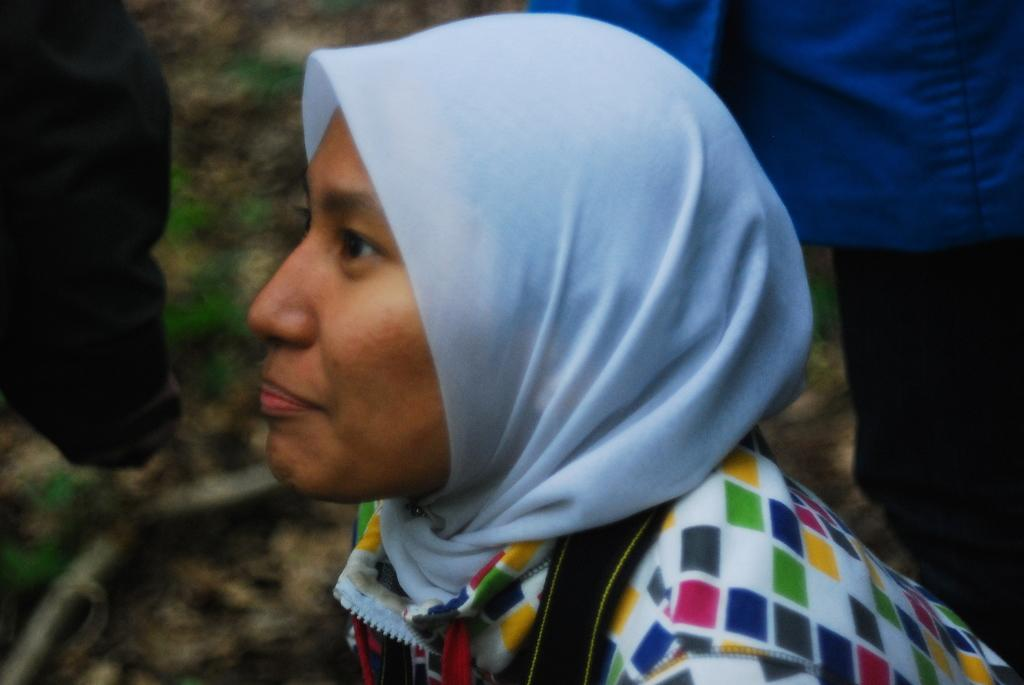Who is the main subject in the image? There is a woman in the image. What is the woman wearing around her neck? The woman is wearing a scarf. What else can be seen in the image besides the woman? There are clothes visible in the image. Can you describe the background of the image? The background of the image is blurred. What type of bird is perched on the owner's shoulder in the image? There is no bird or owner present in the image; it features a woman wearing a scarf and surrounded by clothes. 